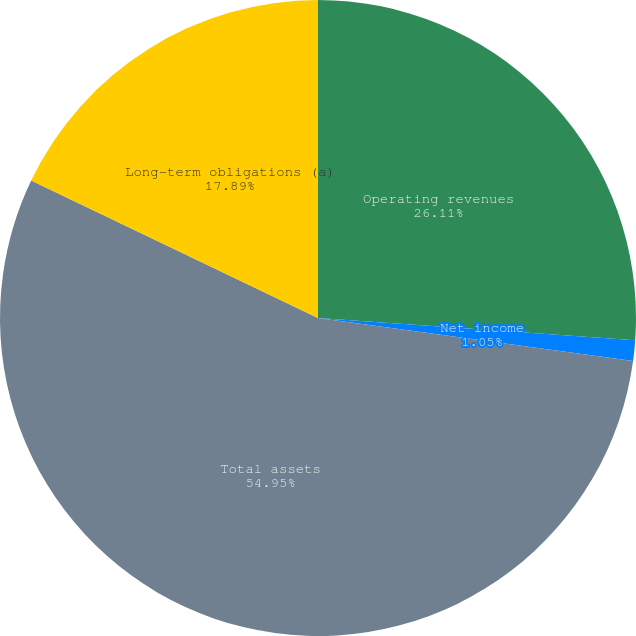<chart> <loc_0><loc_0><loc_500><loc_500><pie_chart><fcel>Operating revenues<fcel>Net income<fcel>Total assets<fcel>Long-term obligations (a)<nl><fcel>26.11%<fcel>1.05%<fcel>54.95%<fcel>17.89%<nl></chart> 